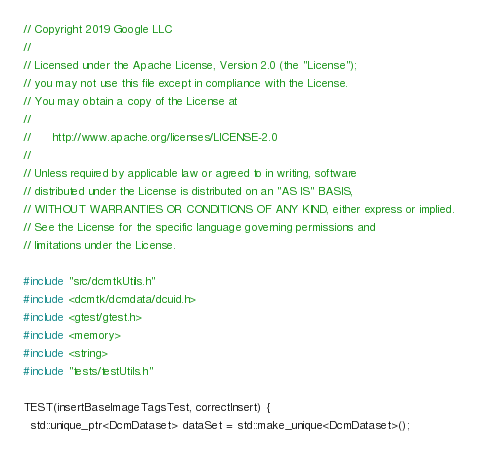Convert code to text. <code><loc_0><loc_0><loc_500><loc_500><_C++_>// Copyright 2019 Google LLC
//
// Licensed under the Apache License, Version 2.0 (the "License");
// you may not use this file except in compliance with the License.
// You may obtain a copy of the License at
//
//      http://www.apache.org/licenses/LICENSE-2.0
//
// Unless required by applicable law or agreed to in writing, software
// distributed under the License is distributed on an "AS IS" BASIS,
// WITHOUT WARRANTIES OR CONDITIONS OF ANY KIND, either express or implied.
// See the License for the specific language governing permissions and
// limitations under the License.

#include "src/dcmtkUtils.h"
#include <dcmtk/dcmdata/dcuid.h>
#include <gtest/gtest.h>
#include <memory>
#include <string>
#include "tests/testUtils.h"

TEST(insertBaseImageTagsTest, correctInsert) {
  std::unique_ptr<DcmDataset> dataSet = std::make_unique<DcmDataset>();
</code> 